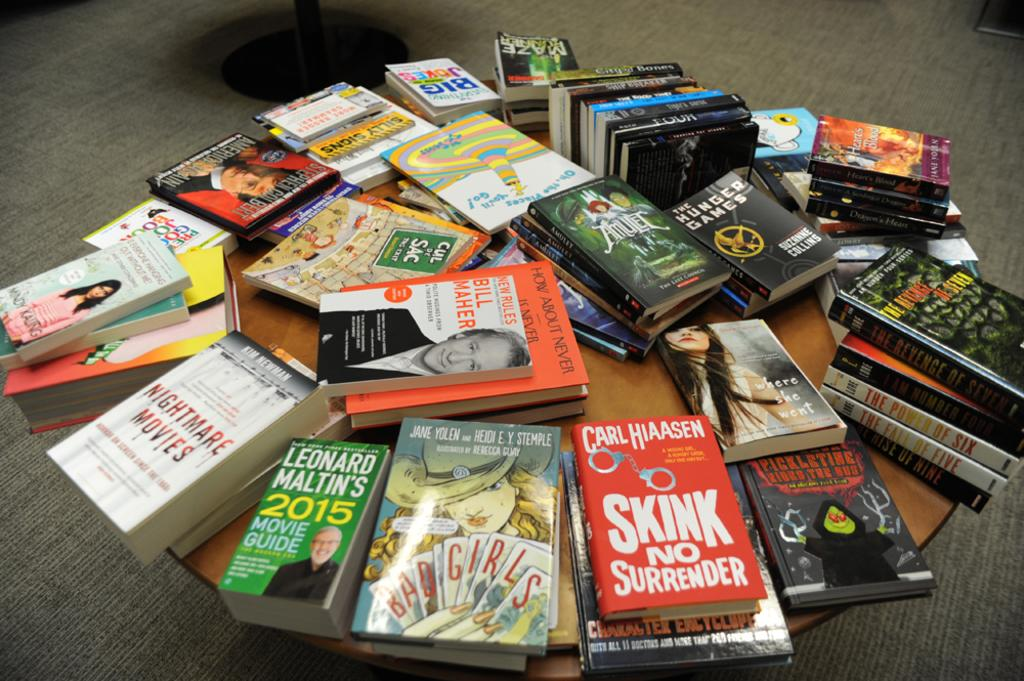<image>
Describe the image concisely. A large collection of books sit on a table, including one entitled Bad Girls. 